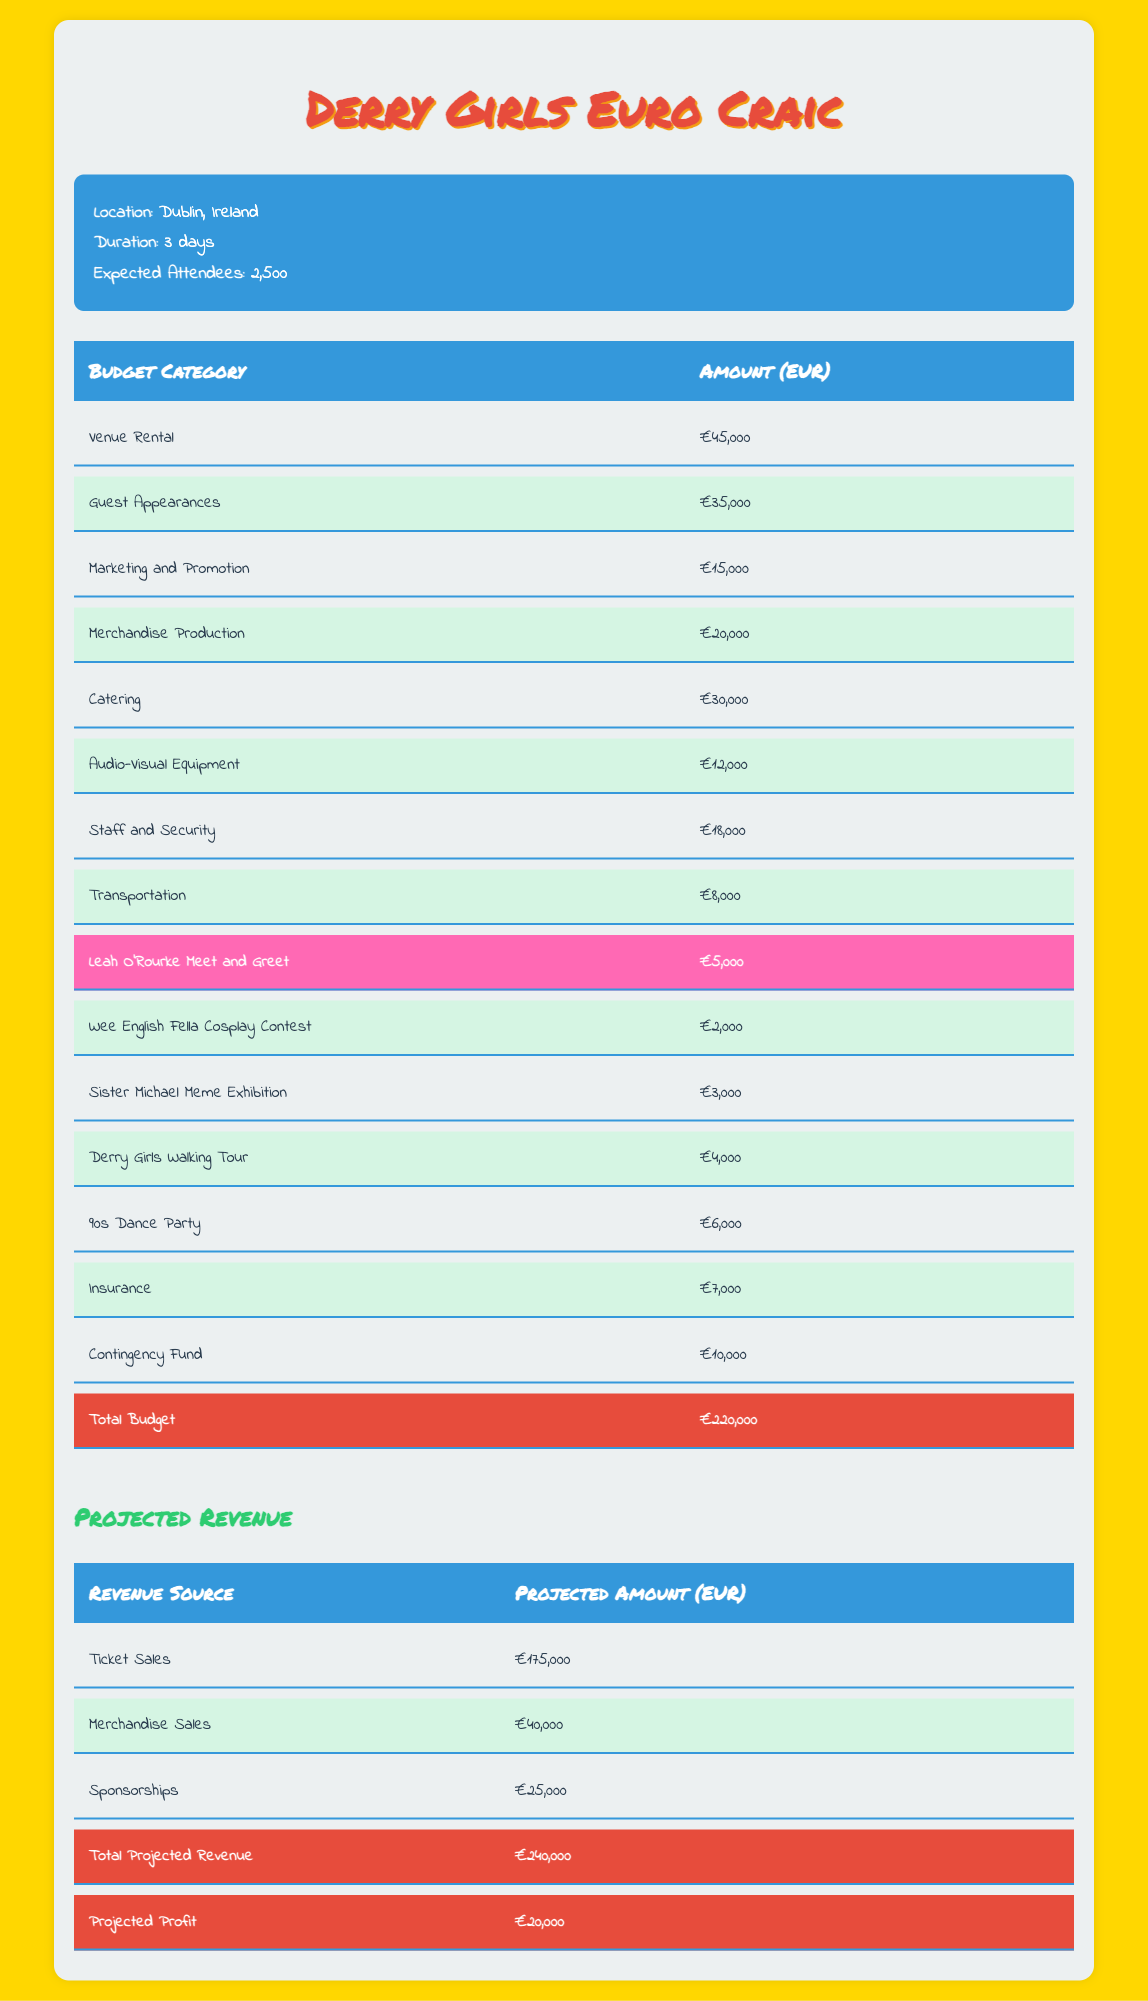What is the total budget allocated for the Derry Girls Euro Craic convention? The total budget is clearly stated in the table under the "Total Budget" category, which shows an amount of €220,000.
Answer: €220,000 How much is allocated for guest appearances? The amount for guest appearances can be found in the table under the "Guest Appearances" category, which lists €35,000.
Answer: €35,000 What percentage of the total budget is earmarked for catering? To find the percentage, divide the catering amount (€30,000) by the total budget (€220,000) and multiply by 100. (30,000 / 220,000) * 100 = 13.64%.
Answer: 13.64% Is the amount for the Leah O'Rourke Meet and Greet less than €10,000? The table shows that the amount for the Leah O'Rourke Meet and Greet is €5,000, which is indeed less than €10,000.
Answer: Yes What is the total projected revenue from ticket sales and merchandise sales? The total projected revenue from ticket sales (€175,000) and merchandise sales (€40,000) can be calculated by summing them: 175,000 + 40,000 = €215,000.
Answer: €215,000 How much more does the total projected revenue exceed the total budget? This can be found by subtracting the total budget (€220,000) from the total projected revenue (€240,000): 240,000 - 220,000 = €20,000.
Answer: €20,000 What is the amount allocated for insurance? The amount for insurance is specifically listed in the table under the "Insurance" category, which states €7,000.
Answer: €7,000 How many categories of budget allocation exceed €20,000? By reviewing the table, we count the categories with amounts over €20,000: Venue Rental (€45,000), Guest Appearances (€35,000), Catering (€30,000), and Merchandise Production (€20,000). This gives us four categories.
Answer: 4 